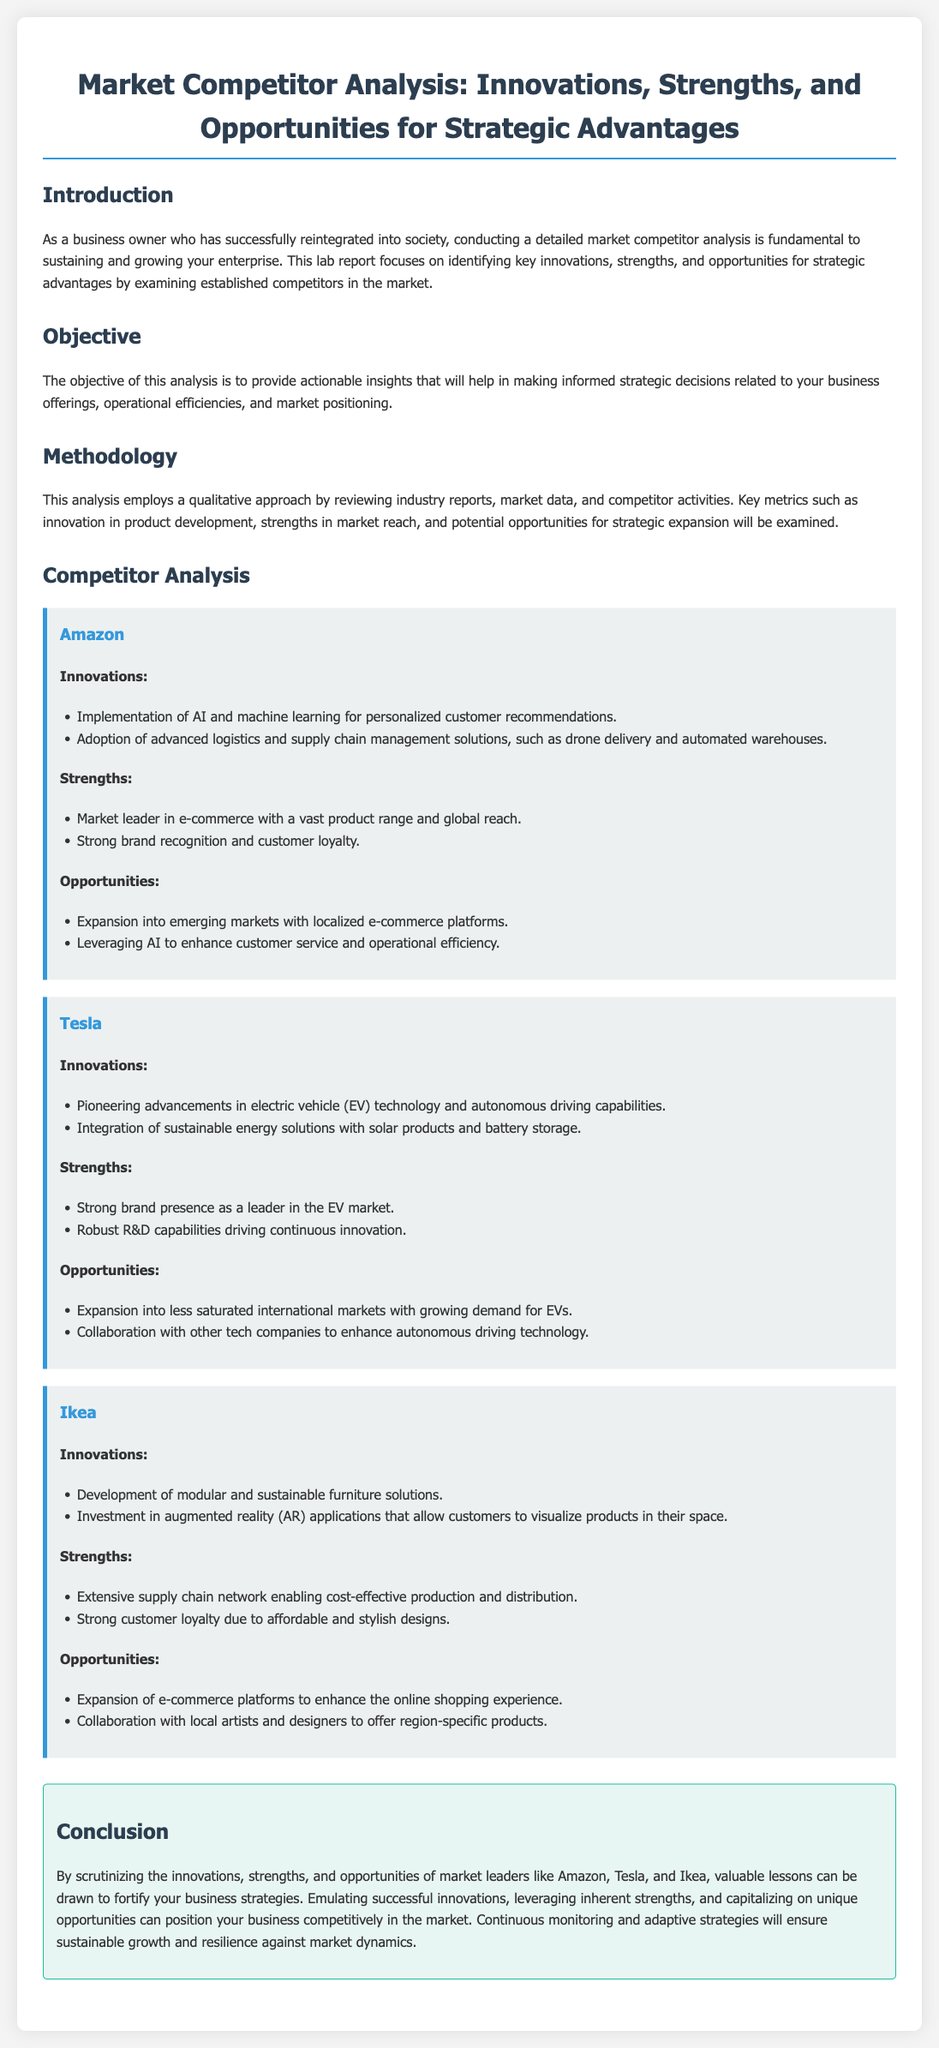What is the focus of the lab report? The lab report focuses on identifying key innovations, strengths, and opportunities for strategic advantages by examining competitors in the market.
Answer: key innovations, strengths, and opportunities Who is the market leader mentioned in the report? The report mentions Amazon as the market leader in e-commerce.
Answer: Amazon What type of approach is used in the analysis? The analysis employs a qualitative approach by reviewing industry reports, market data, and competitor activities.
Answer: qualitative approach Which competitor is noted for advancements in electric vehicle technology? Tesla is noted for pioneering advancements in electric vehicle technology.
Answer: Tesla What are Ikea's innovations related to? Ikea's innovations are related to modular and sustainable furniture solutions and investment in augmented reality applications.
Answer: modular and sustainable furniture solutions What opportunity does Amazon have for expansion? Amazon has the opportunity to expand into emerging markets with localized e-commerce platforms.
Answer: emerging markets with localized e-commerce platforms What does the conclusion suggest for business strategies? The conclusion suggests emulating successful innovations and leveraging inherent strengths for competitive positioning.
Answer: emulating successful innovations and leveraging inherent strengths Which company is recognized for strong research and development capabilities? Tesla is recognized for its robust R&D capabilities driving continuous innovation.
Answer: Tesla What is one of the strengths of Ikea mentioned in the report? One of Ikea's strengths is its extensive supply chain network enabling cost-effective production and distribution.
Answer: extensive supply chain network 